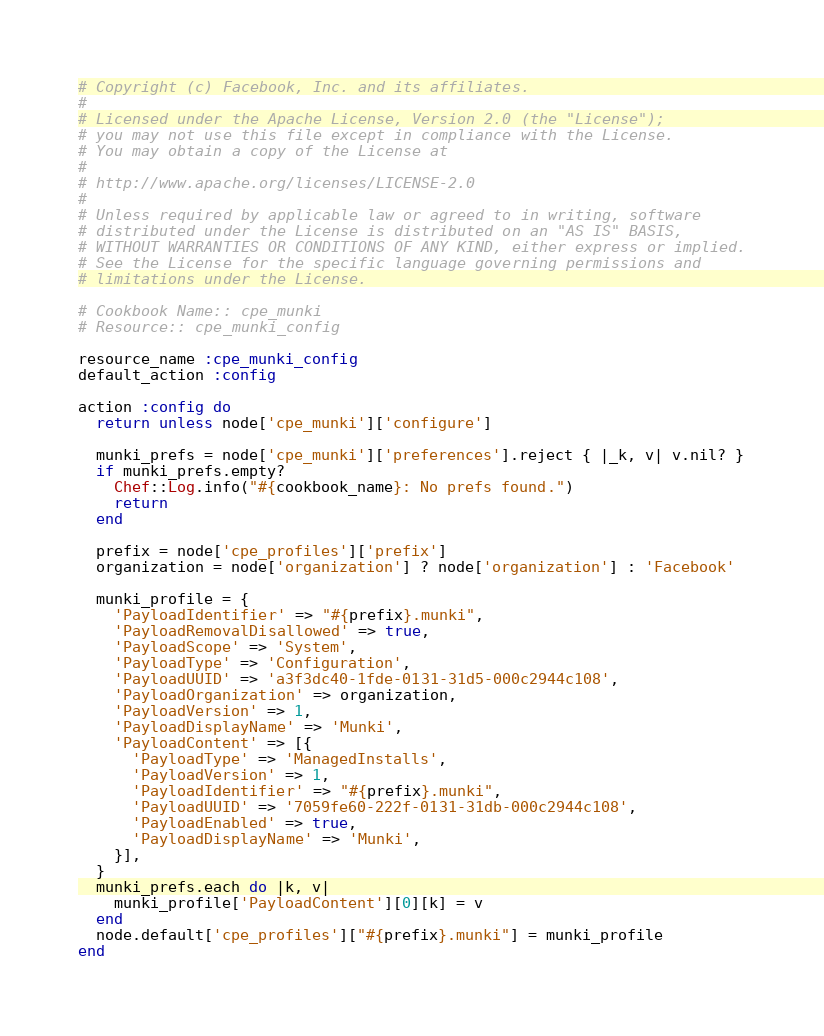Convert code to text. <code><loc_0><loc_0><loc_500><loc_500><_Ruby_># Copyright (c) Facebook, Inc. and its affiliates.
#
# Licensed under the Apache License, Version 2.0 (the "License");
# you may not use this file except in compliance with the License.
# You may obtain a copy of the License at
#
# http://www.apache.org/licenses/LICENSE-2.0
#
# Unless required by applicable law or agreed to in writing, software
# distributed under the License is distributed on an "AS IS" BASIS,
# WITHOUT WARRANTIES OR CONDITIONS OF ANY KIND, either express or implied.
# See the License for the specific language governing permissions and
# limitations under the License.

# Cookbook Name:: cpe_munki
# Resource:: cpe_munki_config

resource_name :cpe_munki_config
default_action :config

action :config do
  return unless node['cpe_munki']['configure']

  munki_prefs = node['cpe_munki']['preferences'].reject { |_k, v| v.nil? }
  if munki_prefs.empty?
    Chef::Log.info("#{cookbook_name}: No prefs found.")
    return
  end

  prefix = node['cpe_profiles']['prefix']
  organization = node['organization'] ? node['organization'] : 'Facebook'

  munki_profile = {
    'PayloadIdentifier' => "#{prefix}.munki",
    'PayloadRemovalDisallowed' => true,
    'PayloadScope' => 'System',
    'PayloadType' => 'Configuration',
    'PayloadUUID' => 'a3f3dc40-1fde-0131-31d5-000c2944c108',
    'PayloadOrganization' => organization,
    'PayloadVersion' => 1,
    'PayloadDisplayName' => 'Munki',
    'PayloadContent' => [{
      'PayloadType' => 'ManagedInstalls',
      'PayloadVersion' => 1,
      'PayloadIdentifier' => "#{prefix}.munki",
      'PayloadUUID' => '7059fe60-222f-0131-31db-000c2944c108',
      'PayloadEnabled' => true,
      'PayloadDisplayName' => 'Munki',
    }],
  }
  munki_prefs.each do |k, v|
    munki_profile['PayloadContent'][0][k] = v
  end
  node.default['cpe_profiles']["#{prefix}.munki"] = munki_profile
end
</code> 